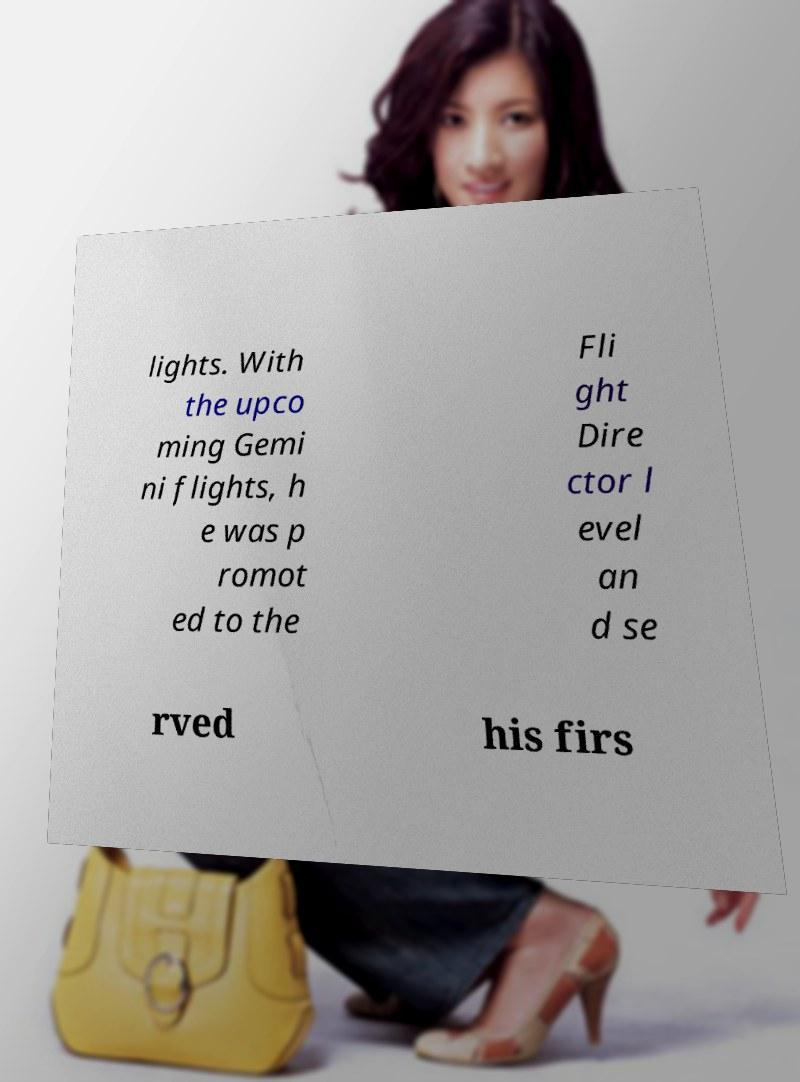Please identify and transcribe the text found in this image. lights. With the upco ming Gemi ni flights, h e was p romot ed to the Fli ght Dire ctor l evel an d se rved his firs 